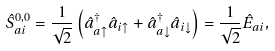<formula> <loc_0><loc_0><loc_500><loc_500>\hat { S } _ { a i } ^ { 0 , 0 } = \frac { 1 } { \sqrt { 2 } } \left ( \hat { a } _ { a \uparrow } ^ { \dag } \hat { a } _ { i \uparrow } + \hat { a } _ { a \downarrow } ^ { \dag } \hat { a } _ { i \downarrow } \right ) = \frac { 1 } { \sqrt { 2 } } \hat { E } _ { a i } ,</formula> 